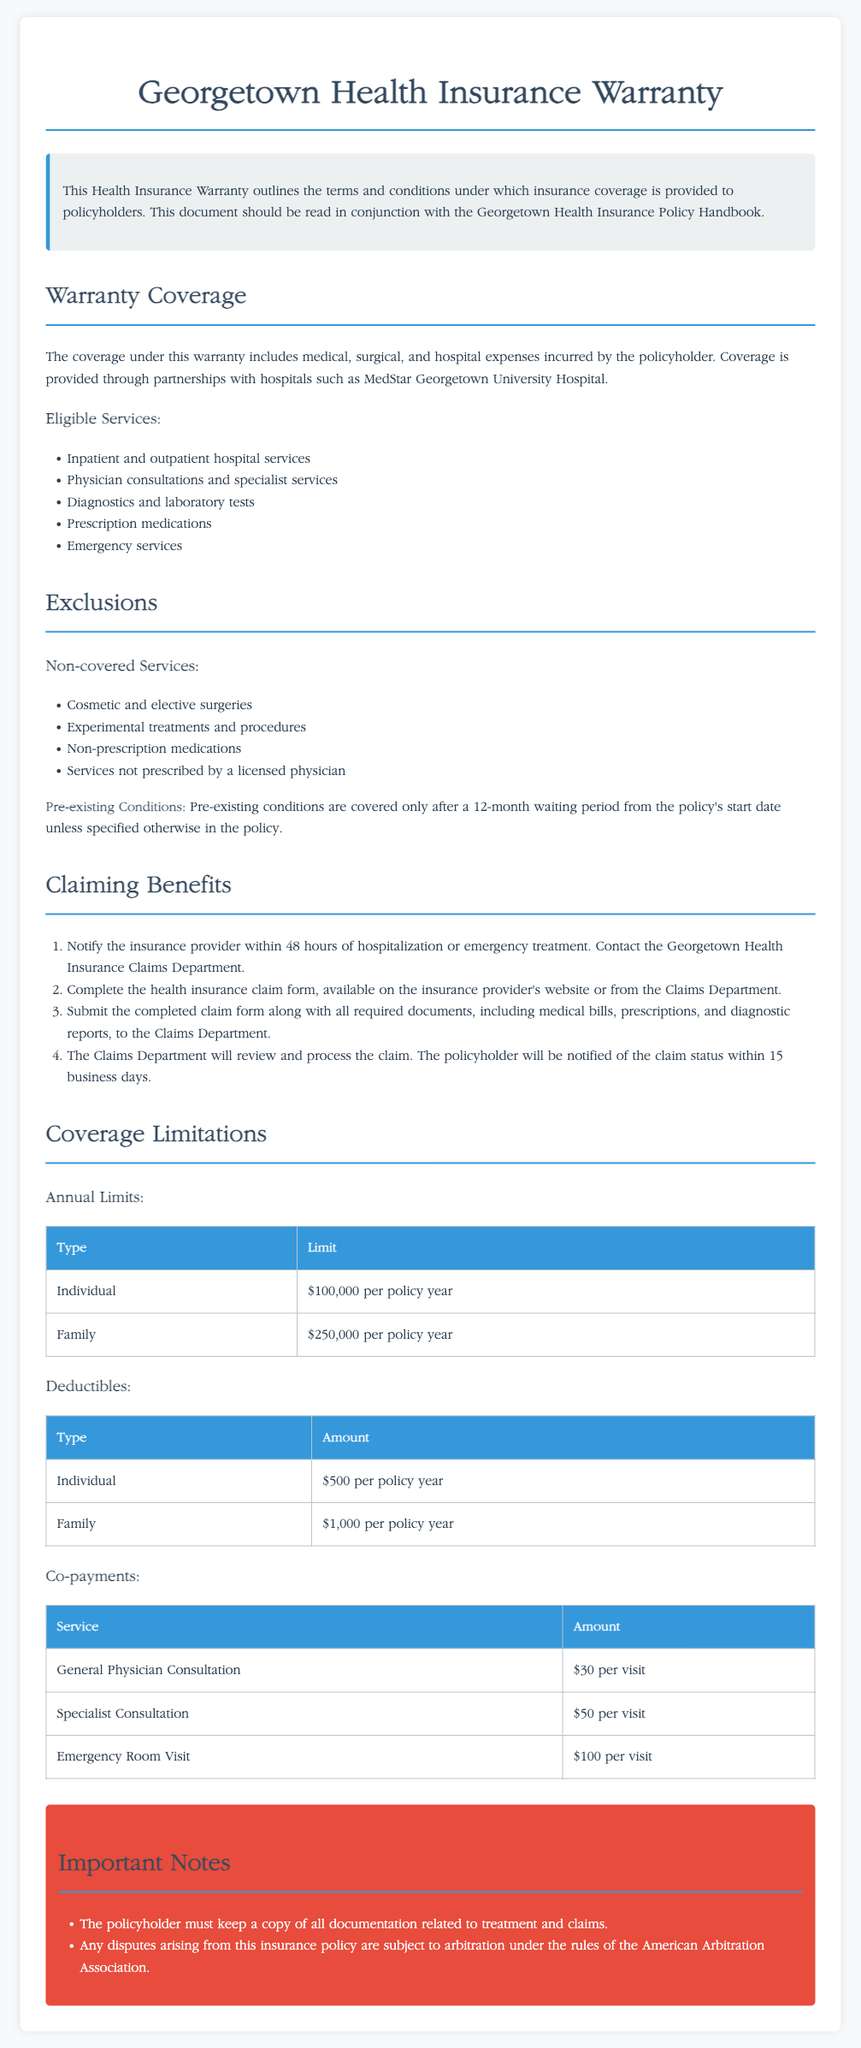What is the annual limit for an individual? The document states the annual limit for an individual as $100,000 per policy year.
Answer: $100,000 What must be notified within 48 hours? The document requires that the insurance provider be notified within 48 hours of hospitalization or emergency treatment.
Answer: Insurance provider What is the deductible amount for a family? According to the document, the deductible amount for a family is $1,000 per policy year.
Answer: $1,000 What type of services are included in eligible services? The document lists inpatient and outpatient hospital services as included in eligible services.
Answer: Inpatient and outpatient hospital services How long will it take to be notified of a claim status? The document specifies that the policyholder will be notified of the claim status within 15 business days.
Answer: 15 business days What is excluded under non-covered services? The document states that cosmetic and elective surgeries are excluded under non-covered services.
Answer: Cosmetic and elective surgeries How long is the waiting period for pre-existing conditions? The document indicates a waiting period of 12 months for pre-existing conditions.
Answer: 12 months What is the co-payment amount for a general physician consultation? The document specifies the co-payment amount for a general physician consultation as $30 per visit.
Answer: $30 per visit What type of claims does this warranty cover? The document outlines that the warranty covers medical, surgical, and hospital expenses.
Answer: Medical, surgical, and hospital expenses 